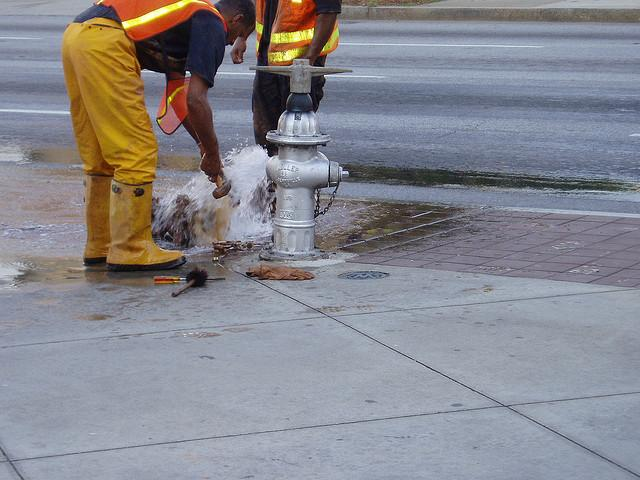Who is paying the person with the hammer?

Choices:
A) city
B) president
C) no one
D) criminals city 